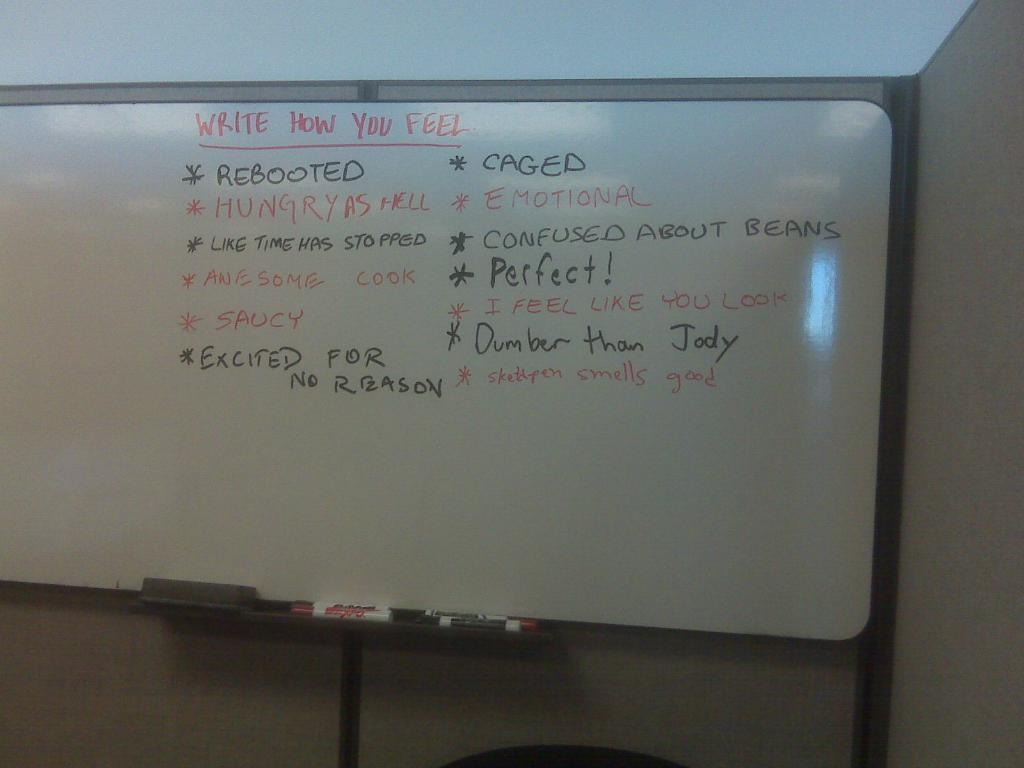<image>
Share a concise interpretation of the image provided. a whiteboard that lets you write how you feel 